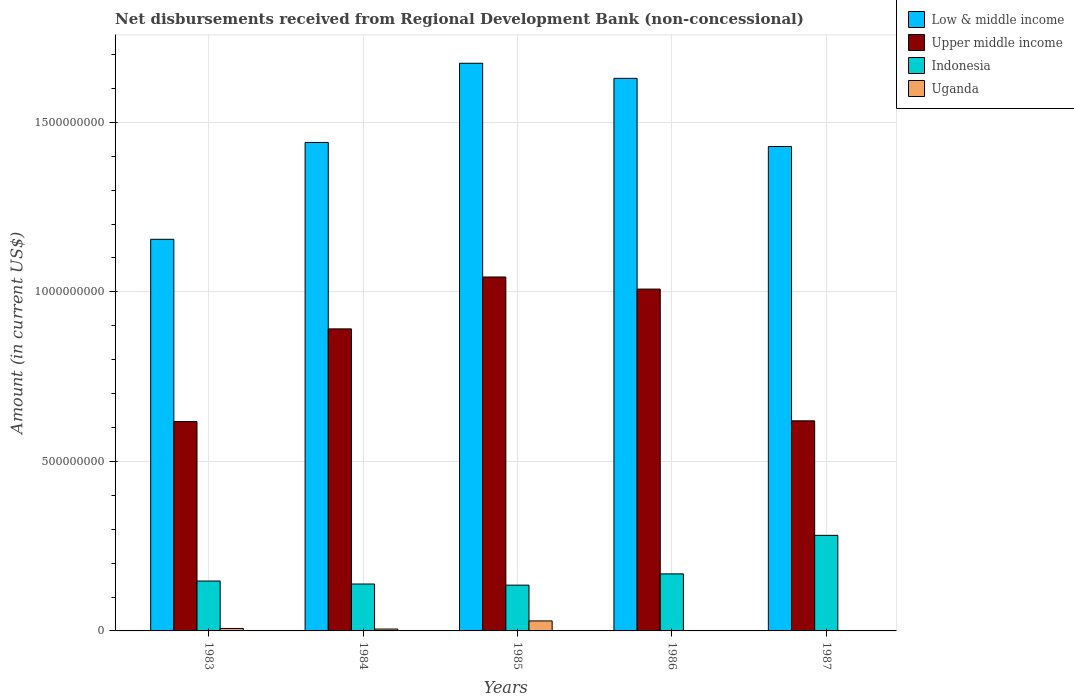How many groups of bars are there?
Your response must be concise. 5. How many bars are there on the 4th tick from the left?
Your response must be concise. 3. How many bars are there on the 2nd tick from the right?
Ensure brevity in your answer.  3. What is the amount of disbursements received from Regional Development Bank in Low & middle income in 1984?
Provide a succinct answer. 1.44e+09. Across all years, what is the maximum amount of disbursements received from Regional Development Bank in Uganda?
Your response must be concise. 2.95e+07. Across all years, what is the minimum amount of disbursements received from Regional Development Bank in Low & middle income?
Offer a very short reply. 1.16e+09. In which year was the amount of disbursements received from Regional Development Bank in Indonesia maximum?
Make the answer very short. 1987. What is the total amount of disbursements received from Regional Development Bank in Indonesia in the graph?
Ensure brevity in your answer.  8.71e+08. What is the difference between the amount of disbursements received from Regional Development Bank in Upper middle income in 1983 and that in 1987?
Make the answer very short. -2.11e+06. What is the difference between the amount of disbursements received from Regional Development Bank in Low & middle income in 1983 and the amount of disbursements received from Regional Development Bank in Upper middle income in 1985?
Make the answer very short. 1.11e+08. What is the average amount of disbursements received from Regional Development Bank in Indonesia per year?
Provide a short and direct response. 1.74e+08. In the year 1985, what is the difference between the amount of disbursements received from Regional Development Bank in Upper middle income and amount of disbursements received from Regional Development Bank in Indonesia?
Your response must be concise. 9.09e+08. What is the ratio of the amount of disbursements received from Regional Development Bank in Upper middle income in 1983 to that in 1984?
Offer a terse response. 0.69. Is the amount of disbursements received from Regional Development Bank in Low & middle income in 1984 less than that in 1986?
Your answer should be very brief. Yes. Is the difference between the amount of disbursements received from Regional Development Bank in Upper middle income in 1983 and 1984 greater than the difference between the amount of disbursements received from Regional Development Bank in Indonesia in 1983 and 1984?
Provide a succinct answer. No. What is the difference between the highest and the second highest amount of disbursements received from Regional Development Bank in Low & middle income?
Make the answer very short. 4.45e+07. What is the difference between the highest and the lowest amount of disbursements received from Regional Development Bank in Low & middle income?
Ensure brevity in your answer.  5.19e+08. Is the sum of the amount of disbursements received from Regional Development Bank in Upper middle income in 1983 and 1984 greater than the maximum amount of disbursements received from Regional Development Bank in Indonesia across all years?
Keep it short and to the point. Yes. Is it the case that in every year, the sum of the amount of disbursements received from Regional Development Bank in Low & middle income and amount of disbursements received from Regional Development Bank in Upper middle income is greater than the sum of amount of disbursements received from Regional Development Bank in Indonesia and amount of disbursements received from Regional Development Bank in Uganda?
Your response must be concise. Yes. Is it the case that in every year, the sum of the amount of disbursements received from Regional Development Bank in Indonesia and amount of disbursements received from Regional Development Bank in Uganda is greater than the amount of disbursements received from Regional Development Bank in Low & middle income?
Your response must be concise. No. How many bars are there?
Offer a very short reply. 19. Does the graph contain any zero values?
Your answer should be very brief. Yes. Where does the legend appear in the graph?
Your answer should be very brief. Top right. How are the legend labels stacked?
Make the answer very short. Vertical. What is the title of the graph?
Make the answer very short. Net disbursements received from Regional Development Bank (non-concessional). Does "Spain" appear as one of the legend labels in the graph?
Provide a short and direct response. No. What is the Amount (in current US$) in Low & middle income in 1983?
Make the answer very short. 1.16e+09. What is the Amount (in current US$) in Upper middle income in 1983?
Your answer should be compact. 6.18e+08. What is the Amount (in current US$) in Indonesia in 1983?
Provide a short and direct response. 1.47e+08. What is the Amount (in current US$) of Uganda in 1983?
Give a very brief answer. 7.27e+06. What is the Amount (in current US$) in Low & middle income in 1984?
Provide a short and direct response. 1.44e+09. What is the Amount (in current US$) in Upper middle income in 1984?
Offer a terse response. 8.91e+08. What is the Amount (in current US$) in Indonesia in 1984?
Your response must be concise. 1.38e+08. What is the Amount (in current US$) in Uganda in 1984?
Give a very brief answer. 5.49e+06. What is the Amount (in current US$) in Low & middle income in 1985?
Your response must be concise. 1.67e+09. What is the Amount (in current US$) in Upper middle income in 1985?
Give a very brief answer. 1.04e+09. What is the Amount (in current US$) in Indonesia in 1985?
Make the answer very short. 1.35e+08. What is the Amount (in current US$) of Uganda in 1985?
Ensure brevity in your answer.  2.95e+07. What is the Amount (in current US$) of Low & middle income in 1986?
Give a very brief answer. 1.63e+09. What is the Amount (in current US$) of Upper middle income in 1986?
Make the answer very short. 1.01e+09. What is the Amount (in current US$) of Indonesia in 1986?
Your answer should be compact. 1.68e+08. What is the Amount (in current US$) in Low & middle income in 1987?
Ensure brevity in your answer.  1.43e+09. What is the Amount (in current US$) in Upper middle income in 1987?
Provide a succinct answer. 6.20e+08. What is the Amount (in current US$) of Indonesia in 1987?
Ensure brevity in your answer.  2.82e+08. What is the Amount (in current US$) in Uganda in 1987?
Ensure brevity in your answer.  2.63e+05. Across all years, what is the maximum Amount (in current US$) of Low & middle income?
Keep it short and to the point. 1.67e+09. Across all years, what is the maximum Amount (in current US$) of Upper middle income?
Keep it short and to the point. 1.04e+09. Across all years, what is the maximum Amount (in current US$) in Indonesia?
Your response must be concise. 2.82e+08. Across all years, what is the maximum Amount (in current US$) in Uganda?
Your answer should be very brief. 2.95e+07. Across all years, what is the minimum Amount (in current US$) of Low & middle income?
Your response must be concise. 1.16e+09. Across all years, what is the minimum Amount (in current US$) of Upper middle income?
Your answer should be compact. 6.18e+08. Across all years, what is the minimum Amount (in current US$) in Indonesia?
Provide a succinct answer. 1.35e+08. Across all years, what is the minimum Amount (in current US$) of Uganda?
Offer a terse response. 0. What is the total Amount (in current US$) in Low & middle income in the graph?
Your answer should be compact. 7.33e+09. What is the total Amount (in current US$) of Upper middle income in the graph?
Make the answer very short. 4.18e+09. What is the total Amount (in current US$) in Indonesia in the graph?
Make the answer very short. 8.71e+08. What is the total Amount (in current US$) in Uganda in the graph?
Offer a terse response. 4.25e+07. What is the difference between the Amount (in current US$) of Low & middle income in 1983 and that in 1984?
Offer a terse response. -2.86e+08. What is the difference between the Amount (in current US$) of Upper middle income in 1983 and that in 1984?
Provide a short and direct response. -2.73e+08. What is the difference between the Amount (in current US$) in Indonesia in 1983 and that in 1984?
Offer a very short reply. 8.79e+06. What is the difference between the Amount (in current US$) in Uganda in 1983 and that in 1984?
Provide a succinct answer. 1.78e+06. What is the difference between the Amount (in current US$) of Low & middle income in 1983 and that in 1985?
Provide a short and direct response. -5.19e+08. What is the difference between the Amount (in current US$) in Upper middle income in 1983 and that in 1985?
Your answer should be very brief. -4.26e+08. What is the difference between the Amount (in current US$) of Indonesia in 1983 and that in 1985?
Your answer should be very brief. 1.21e+07. What is the difference between the Amount (in current US$) in Uganda in 1983 and that in 1985?
Make the answer very short. -2.22e+07. What is the difference between the Amount (in current US$) of Low & middle income in 1983 and that in 1986?
Ensure brevity in your answer.  -4.75e+08. What is the difference between the Amount (in current US$) in Upper middle income in 1983 and that in 1986?
Give a very brief answer. -3.91e+08. What is the difference between the Amount (in current US$) of Indonesia in 1983 and that in 1986?
Ensure brevity in your answer.  -2.11e+07. What is the difference between the Amount (in current US$) in Low & middle income in 1983 and that in 1987?
Ensure brevity in your answer.  -2.74e+08. What is the difference between the Amount (in current US$) in Upper middle income in 1983 and that in 1987?
Your response must be concise. -2.11e+06. What is the difference between the Amount (in current US$) of Indonesia in 1983 and that in 1987?
Ensure brevity in your answer.  -1.35e+08. What is the difference between the Amount (in current US$) in Uganda in 1983 and that in 1987?
Your answer should be very brief. 7.01e+06. What is the difference between the Amount (in current US$) of Low & middle income in 1984 and that in 1985?
Give a very brief answer. -2.34e+08. What is the difference between the Amount (in current US$) of Upper middle income in 1984 and that in 1985?
Your answer should be very brief. -1.53e+08. What is the difference between the Amount (in current US$) in Indonesia in 1984 and that in 1985?
Provide a short and direct response. 3.32e+06. What is the difference between the Amount (in current US$) in Uganda in 1984 and that in 1985?
Make the answer very short. -2.40e+07. What is the difference between the Amount (in current US$) in Low & middle income in 1984 and that in 1986?
Your answer should be very brief. -1.89e+08. What is the difference between the Amount (in current US$) of Upper middle income in 1984 and that in 1986?
Your answer should be compact. -1.17e+08. What is the difference between the Amount (in current US$) in Indonesia in 1984 and that in 1986?
Ensure brevity in your answer.  -2.99e+07. What is the difference between the Amount (in current US$) of Low & middle income in 1984 and that in 1987?
Give a very brief answer. 1.20e+07. What is the difference between the Amount (in current US$) in Upper middle income in 1984 and that in 1987?
Provide a short and direct response. 2.71e+08. What is the difference between the Amount (in current US$) in Indonesia in 1984 and that in 1987?
Make the answer very short. -1.44e+08. What is the difference between the Amount (in current US$) in Uganda in 1984 and that in 1987?
Offer a very short reply. 5.23e+06. What is the difference between the Amount (in current US$) of Low & middle income in 1985 and that in 1986?
Your answer should be very brief. 4.45e+07. What is the difference between the Amount (in current US$) in Upper middle income in 1985 and that in 1986?
Your answer should be compact. 3.57e+07. What is the difference between the Amount (in current US$) in Indonesia in 1985 and that in 1986?
Your response must be concise. -3.32e+07. What is the difference between the Amount (in current US$) in Low & middle income in 1985 and that in 1987?
Provide a succinct answer. 2.46e+08. What is the difference between the Amount (in current US$) in Upper middle income in 1985 and that in 1987?
Make the answer very short. 4.24e+08. What is the difference between the Amount (in current US$) in Indonesia in 1985 and that in 1987?
Offer a terse response. -1.47e+08. What is the difference between the Amount (in current US$) in Uganda in 1985 and that in 1987?
Your response must be concise. 2.92e+07. What is the difference between the Amount (in current US$) in Low & middle income in 1986 and that in 1987?
Your response must be concise. 2.01e+08. What is the difference between the Amount (in current US$) in Upper middle income in 1986 and that in 1987?
Give a very brief answer. 3.89e+08. What is the difference between the Amount (in current US$) in Indonesia in 1986 and that in 1987?
Your answer should be compact. -1.14e+08. What is the difference between the Amount (in current US$) of Low & middle income in 1983 and the Amount (in current US$) of Upper middle income in 1984?
Make the answer very short. 2.64e+08. What is the difference between the Amount (in current US$) in Low & middle income in 1983 and the Amount (in current US$) in Indonesia in 1984?
Your response must be concise. 1.02e+09. What is the difference between the Amount (in current US$) of Low & middle income in 1983 and the Amount (in current US$) of Uganda in 1984?
Your answer should be very brief. 1.15e+09. What is the difference between the Amount (in current US$) in Upper middle income in 1983 and the Amount (in current US$) in Indonesia in 1984?
Provide a succinct answer. 4.79e+08. What is the difference between the Amount (in current US$) of Upper middle income in 1983 and the Amount (in current US$) of Uganda in 1984?
Provide a short and direct response. 6.12e+08. What is the difference between the Amount (in current US$) of Indonesia in 1983 and the Amount (in current US$) of Uganda in 1984?
Ensure brevity in your answer.  1.42e+08. What is the difference between the Amount (in current US$) of Low & middle income in 1983 and the Amount (in current US$) of Upper middle income in 1985?
Your answer should be compact. 1.11e+08. What is the difference between the Amount (in current US$) in Low & middle income in 1983 and the Amount (in current US$) in Indonesia in 1985?
Your answer should be very brief. 1.02e+09. What is the difference between the Amount (in current US$) in Low & middle income in 1983 and the Amount (in current US$) in Uganda in 1985?
Provide a short and direct response. 1.13e+09. What is the difference between the Amount (in current US$) in Upper middle income in 1983 and the Amount (in current US$) in Indonesia in 1985?
Ensure brevity in your answer.  4.82e+08. What is the difference between the Amount (in current US$) of Upper middle income in 1983 and the Amount (in current US$) of Uganda in 1985?
Offer a terse response. 5.88e+08. What is the difference between the Amount (in current US$) of Indonesia in 1983 and the Amount (in current US$) of Uganda in 1985?
Provide a succinct answer. 1.18e+08. What is the difference between the Amount (in current US$) of Low & middle income in 1983 and the Amount (in current US$) of Upper middle income in 1986?
Provide a succinct answer. 1.47e+08. What is the difference between the Amount (in current US$) of Low & middle income in 1983 and the Amount (in current US$) of Indonesia in 1986?
Provide a short and direct response. 9.87e+08. What is the difference between the Amount (in current US$) in Upper middle income in 1983 and the Amount (in current US$) in Indonesia in 1986?
Your answer should be compact. 4.49e+08. What is the difference between the Amount (in current US$) in Low & middle income in 1983 and the Amount (in current US$) in Upper middle income in 1987?
Your response must be concise. 5.35e+08. What is the difference between the Amount (in current US$) in Low & middle income in 1983 and the Amount (in current US$) in Indonesia in 1987?
Offer a terse response. 8.73e+08. What is the difference between the Amount (in current US$) in Low & middle income in 1983 and the Amount (in current US$) in Uganda in 1987?
Your answer should be compact. 1.15e+09. What is the difference between the Amount (in current US$) of Upper middle income in 1983 and the Amount (in current US$) of Indonesia in 1987?
Provide a succinct answer. 3.36e+08. What is the difference between the Amount (in current US$) of Upper middle income in 1983 and the Amount (in current US$) of Uganda in 1987?
Provide a succinct answer. 6.17e+08. What is the difference between the Amount (in current US$) in Indonesia in 1983 and the Amount (in current US$) in Uganda in 1987?
Ensure brevity in your answer.  1.47e+08. What is the difference between the Amount (in current US$) in Low & middle income in 1984 and the Amount (in current US$) in Upper middle income in 1985?
Give a very brief answer. 3.97e+08. What is the difference between the Amount (in current US$) in Low & middle income in 1984 and the Amount (in current US$) in Indonesia in 1985?
Provide a short and direct response. 1.31e+09. What is the difference between the Amount (in current US$) in Low & middle income in 1984 and the Amount (in current US$) in Uganda in 1985?
Your response must be concise. 1.41e+09. What is the difference between the Amount (in current US$) in Upper middle income in 1984 and the Amount (in current US$) in Indonesia in 1985?
Your answer should be very brief. 7.56e+08. What is the difference between the Amount (in current US$) of Upper middle income in 1984 and the Amount (in current US$) of Uganda in 1985?
Provide a short and direct response. 8.61e+08. What is the difference between the Amount (in current US$) of Indonesia in 1984 and the Amount (in current US$) of Uganda in 1985?
Keep it short and to the point. 1.09e+08. What is the difference between the Amount (in current US$) in Low & middle income in 1984 and the Amount (in current US$) in Upper middle income in 1986?
Your response must be concise. 4.32e+08. What is the difference between the Amount (in current US$) in Low & middle income in 1984 and the Amount (in current US$) in Indonesia in 1986?
Your answer should be compact. 1.27e+09. What is the difference between the Amount (in current US$) in Upper middle income in 1984 and the Amount (in current US$) in Indonesia in 1986?
Keep it short and to the point. 7.23e+08. What is the difference between the Amount (in current US$) of Low & middle income in 1984 and the Amount (in current US$) of Upper middle income in 1987?
Your answer should be very brief. 8.21e+08. What is the difference between the Amount (in current US$) of Low & middle income in 1984 and the Amount (in current US$) of Indonesia in 1987?
Provide a succinct answer. 1.16e+09. What is the difference between the Amount (in current US$) in Low & middle income in 1984 and the Amount (in current US$) in Uganda in 1987?
Provide a succinct answer. 1.44e+09. What is the difference between the Amount (in current US$) in Upper middle income in 1984 and the Amount (in current US$) in Indonesia in 1987?
Offer a terse response. 6.09e+08. What is the difference between the Amount (in current US$) in Upper middle income in 1984 and the Amount (in current US$) in Uganda in 1987?
Ensure brevity in your answer.  8.91e+08. What is the difference between the Amount (in current US$) in Indonesia in 1984 and the Amount (in current US$) in Uganda in 1987?
Keep it short and to the point. 1.38e+08. What is the difference between the Amount (in current US$) in Low & middle income in 1985 and the Amount (in current US$) in Upper middle income in 1986?
Provide a succinct answer. 6.66e+08. What is the difference between the Amount (in current US$) of Low & middle income in 1985 and the Amount (in current US$) of Indonesia in 1986?
Offer a very short reply. 1.51e+09. What is the difference between the Amount (in current US$) in Upper middle income in 1985 and the Amount (in current US$) in Indonesia in 1986?
Provide a short and direct response. 8.76e+08. What is the difference between the Amount (in current US$) of Low & middle income in 1985 and the Amount (in current US$) of Upper middle income in 1987?
Give a very brief answer. 1.05e+09. What is the difference between the Amount (in current US$) in Low & middle income in 1985 and the Amount (in current US$) in Indonesia in 1987?
Offer a terse response. 1.39e+09. What is the difference between the Amount (in current US$) in Low & middle income in 1985 and the Amount (in current US$) in Uganda in 1987?
Make the answer very short. 1.67e+09. What is the difference between the Amount (in current US$) in Upper middle income in 1985 and the Amount (in current US$) in Indonesia in 1987?
Make the answer very short. 7.62e+08. What is the difference between the Amount (in current US$) in Upper middle income in 1985 and the Amount (in current US$) in Uganda in 1987?
Your answer should be compact. 1.04e+09. What is the difference between the Amount (in current US$) of Indonesia in 1985 and the Amount (in current US$) of Uganda in 1987?
Ensure brevity in your answer.  1.35e+08. What is the difference between the Amount (in current US$) in Low & middle income in 1986 and the Amount (in current US$) in Upper middle income in 1987?
Make the answer very short. 1.01e+09. What is the difference between the Amount (in current US$) of Low & middle income in 1986 and the Amount (in current US$) of Indonesia in 1987?
Give a very brief answer. 1.35e+09. What is the difference between the Amount (in current US$) of Low & middle income in 1986 and the Amount (in current US$) of Uganda in 1987?
Offer a very short reply. 1.63e+09. What is the difference between the Amount (in current US$) of Upper middle income in 1986 and the Amount (in current US$) of Indonesia in 1987?
Give a very brief answer. 7.26e+08. What is the difference between the Amount (in current US$) in Upper middle income in 1986 and the Amount (in current US$) in Uganda in 1987?
Provide a short and direct response. 1.01e+09. What is the difference between the Amount (in current US$) of Indonesia in 1986 and the Amount (in current US$) of Uganda in 1987?
Offer a terse response. 1.68e+08. What is the average Amount (in current US$) of Low & middle income per year?
Your answer should be very brief. 1.47e+09. What is the average Amount (in current US$) of Upper middle income per year?
Provide a short and direct response. 8.36e+08. What is the average Amount (in current US$) in Indonesia per year?
Give a very brief answer. 1.74e+08. What is the average Amount (in current US$) in Uganda per year?
Make the answer very short. 8.50e+06. In the year 1983, what is the difference between the Amount (in current US$) in Low & middle income and Amount (in current US$) in Upper middle income?
Give a very brief answer. 5.38e+08. In the year 1983, what is the difference between the Amount (in current US$) in Low & middle income and Amount (in current US$) in Indonesia?
Offer a terse response. 1.01e+09. In the year 1983, what is the difference between the Amount (in current US$) of Low & middle income and Amount (in current US$) of Uganda?
Provide a short and direct response. 1.15e+09. In the year 1983, what is the difference between the Amount (in current US$) of Upper middle income and Amount (in current US$) of Indonesia?
Your answer should be compact. 4.70e+08. In the year 1983, what is the difference between the Amount (in current US$) of Upper middle income and Amount (in current US$) of Uganda?
Provide a succinct answer. 6.10e+08. In the year 1983, what is the difference between the Amount (in current US$) in Indonesia and Amount (in current US$) in Uganda?
Ensure brevity in your answer.  1.40e+08. In the year 1984, what is the difference between the Amount (in current US$) in Low & middle income and Amount (in current US$) in Upper middle income?
Provide a short and direct response. 5.50e+08. In the year 1984, what is the difference between the Amount (in current US$) in Low & middle income and Amount (in current US$) in Indonesia?
Make the answer very short. 1.30e+09. In the year 1984, what is the difference between the Amount (in current US$) of Low & middle income and Amount (in current US$) of Uganda?
Your answer should be very brief. 1.44e+09. In the year 1984, what is the difference between the Amount (in current US$) in Upper middle income and Amount (in current US$) in Indonesia?
Make the answer very short. 7.52e+08. In the year 1984, what is the difference between the Amount (in current US$) of Upper middle income and Amount (in current US$) of Uganda?
Keep it short and to the point. 8.85e+08. In the year 1984, what is the difference between the Amount (in current US$) in Indonesia and Amount (in current US$) in Uganda?
Offer a terse response. 1.33e+08. In the year 1985, what is the difference between the Amount (in current US$) of Low & middle income and Amount (in current US$) of Upper middle income?
Keep it short and to the point. 6.30e+08. In the year 1985, what is the difference between the Amount (in current US$) of Low & middle income and Amount (in current US$) of Indonesia?
Keep it short and to the point. 1.54e+09. In the year 1985, what is the difference between the Amount (in current US$) in Low & middle income and Amount (in current US$) in Uganda?
Provide a succinct answer. 1.64e+09. In the year 1985, what is the difference between the Amount (in current US$) of Upper middle income and Amount (in current US$) of Indonesia?
Your answer should be compact. 9.09e+08. In the year 1985, what is the difference between the Amount (in current US$) in Upper middle income and Amount (in current US$) in Uganda?
Offer a very short reply. 1.01e+09. In the year 1985, what is the difference between the Amount (in current US$) in Indonesia and Amount (in current US$) in Uganda?
Make the answer very short. 1.06e+08. In the year 1986, what is the difference between the Amount (in current US$) in Low & middle income and Amount (in current US$) in Upper middle income?
Make the answer very short. 6.22e+08. In the year 1986, what is the difference between the Amount (in current US$) of Low & middle income and Amount (in current US$) of Indonesia?
Your answer should be compact. 1.46e+09. In the year 1986, what is the difference between the Amount (in current US$) of Upper middle income and Amount (in current US$) of Indonesia?
Offer a very short reply. 8.40e+08. In the year 1987, what is the difference between the Amount (in current US$) in Low & middle income and Amount (in current US$) in Upper middle income?
Provide a succinct answer. 8.09e+08. In the year 1987, what is the difference between the Amount (in current US$) in Low & middle income and Amount (in current US$) in Indonesia?
Your answer should be very brief. 1.15e+09. In the year 1987, what is the difference between the Amount (in current US$) of Low & middle income and Amount (in current US$) of Uganda?
Offer a very short reply. 1.43e+09. In the year 1987, what is the difference between the Amount (in current US$) in Upper middle income and Amount (in current US$) in Indonesia?
Offer a terse response. 3.38e+08. In the year 1987, what is the difference between the Amount (in current US$) in Upper middle income and Amount (in current US$) in Uganda?
Offer a very short reply. 6.19e+08. In the year 1987, what is the difference between the Amount (in current US$) of Indonesia and Amount (in current US$) of Uganda?
Offer a very short reply. 2.82e+08. What is the ratio of the Amount (in current US$) in Low & middle income in 1983 to that in 1984?
Make the answer very short. 0.8. What is the ratio of the Amount (in current US$) of Upper middle income in 1983 to that in 1984?
Offer a very short reply. 0.69. What is the ratio of the Amount (in current US$) of Indonesia in 1983 to that in 1984?
Provide a succinct answer. 1.06. What is the ratio of the Amount (in current US$) of Uganda in 1983 to that in 1984?
Keep it short and to the point. 1.32. What is the ratio of the Amount (in current US$) of Low & middle income in 1983 to that in 1985?
Your answer should be very brief. 0.69. What is the ratio of the Amount (in current US$) in Upper middle income in 1983 to that in 1985?
Offer a very short reply. 0.59. What is the ratio of the Amount (in current US$) in Indonesia in 1983 to that in 1985?
Offer a terse response. 1.09. What is the ratio of the Amount (in current US$) in Uganda in 1983 to that in 1985?
Offer a terse response. 0.25. What is the ratio of the Amount (in current US$) in Low & middle income in 1983 to that in 1986?
Your answer should be very brief. 0.71. What is the ratio of the Amount (in current US$) in Upper middle income in 1983 to that in 1986?
Your response must be concise. 0.61. What is the ratio of the Amount (in current US$) in Indonesia in 1983 to that in 1986?
Offer a very short reply. 0.87. What is the ratio of the Amount (in current US$) in Low & middle income in 1983 to that in 1987?
Make the answer very short. 0.81. What is the ratio of the Amount (in current US$) in Upper middle income in 1983 to that in 1987?
Offer a very short reply. 1. What is the ratio of the Amount (in current US$) in Indonesia in 1983 to that in 1987?
Offer a terse response. 0.52. What is the ratio of the Amount (in current US$) of Uganda in 1983 to that in 1987?
Offer a very short reply. 27.64. What is the ratio of the Amount (in current US$) of Low & middle income in 1984 to that in 1985?
Your answer should be compact. 0.86. What is the ratio of the Amount (in current US$) of Upper middle income in 1984 to that in 1985?
Offer a very short reply. 0.85. What is the ratio of the Amount (in current US$) of Indonesia in 1984 to that in 1985?
Your answer should be compact. 1.02. What is the ratio of the Amount (in current US$) of Uganda in 1984 to that in 1985?
Your answer should be compact. 0.19. What is the ratio of the Amount (in current US$) of Low & middle income in 1984 to that in 1986?
Your response must be concise. 0.88. What is the ratio of the Amount (in current US$) in Upper middle income in 1984 to that in 1986?
Provide a succinct answer. 0.88. What is the ratio of the Amount (in current US$) of Indonesia in 1984 to that in 1986?
Make the answer very short. 0.82. What is the ratio of the Amount (in current US$) of Low & middle income in 1984 to that in 1987?
Ensure brevity in your answer.  1.01. What is the ratio of the Amount (in current US$) in Upper middle income in 1984 to that in 1987?
Make the answer very short. 1.44. What is the ratio of the Amount (in current US$) in Indonesia in 1984 to that in 1987?
Offer a terse response. 0.49. What is the ratio of the Amount (in current US$) in Uganda in 1984 to that in 1987?
Make the answer very short. 20.87. What is the ratio of the Amount (in current US$) in Low & middle income in 1985 to that in 1986?
Give a very brief answer. 1.03. What is the ratio of the Amount (in current US$) of Upper middle income in 1985 to that in 1986?
Your answer should be very brief. 1.04. What is the ratio of the Amount (in current US$) in Indonesia in 1985 to that in 1986?
Make the answer very short. 0.8. What is the ratio of the Amount (in current US$) of Low & middle income in 1985 to that in 1987?
Your response must be concise. 1.17. What is the ratio of the Amount (in current US$) of Upper middle income in 1985 to that in 1987?
Provide a short and direct response. 1.68. What is the ratio of the Amount (in current US$) in Indonesia in 1985 to that in 1987?
Give a very brief answer. 0.48. What is the ratio of the Amount (in current US$) in Uganda in 1985 to that in 1987?
Your response must be concise. 112.02. What is the ratio of the Amount (in current US$) in Low & middle income in 1986 to that in 1987?
Give a very brief answer. 1.14. What is the ratio of the Amount (in current US$) in Upper middle income in 1986 to that in 1987?
Offer a terse response. 1.63. What is the ratio of the Amount (in current US$) of Indonesia in 1986 to that in 1987?
Make the answer very short. 0.6. What is the difference between the highest and the second highest Amount (in current US$) of Low & middle income?
Your response must be concise. 4.45e+07. What is the difference between the highest and the second highest Amount (in current US$) of Upper middle income?
Give a very brief answer. 3.57e+07. What is the difference between the highest and the second highest Amount (in current US$) in Indonesia?
Make the answer very short. 1.14e+08. What is the difference between the highest and the second highest Amount (in current US$) in Uganda?
Give a very brief answer. 2.22e+07. What is the difference between the highest and the lowest Amount (in current US$) in Low & middle income?
Provide a short and direct response. 5.19e+08. What is the difference between the highest and the lowest Amount (in current US$) in Upper middle income?
Ensure brevity in your answer.  4.26e+08. What is the difference between the highest and the lowest Amount (in current US$) in Indonesia?
Your answer should be very brief. 1.47e+08. What is the difference between the highest and the lowest Amount (in current US$) in Uganda?
Offer a terse response. 2.95e+07. 